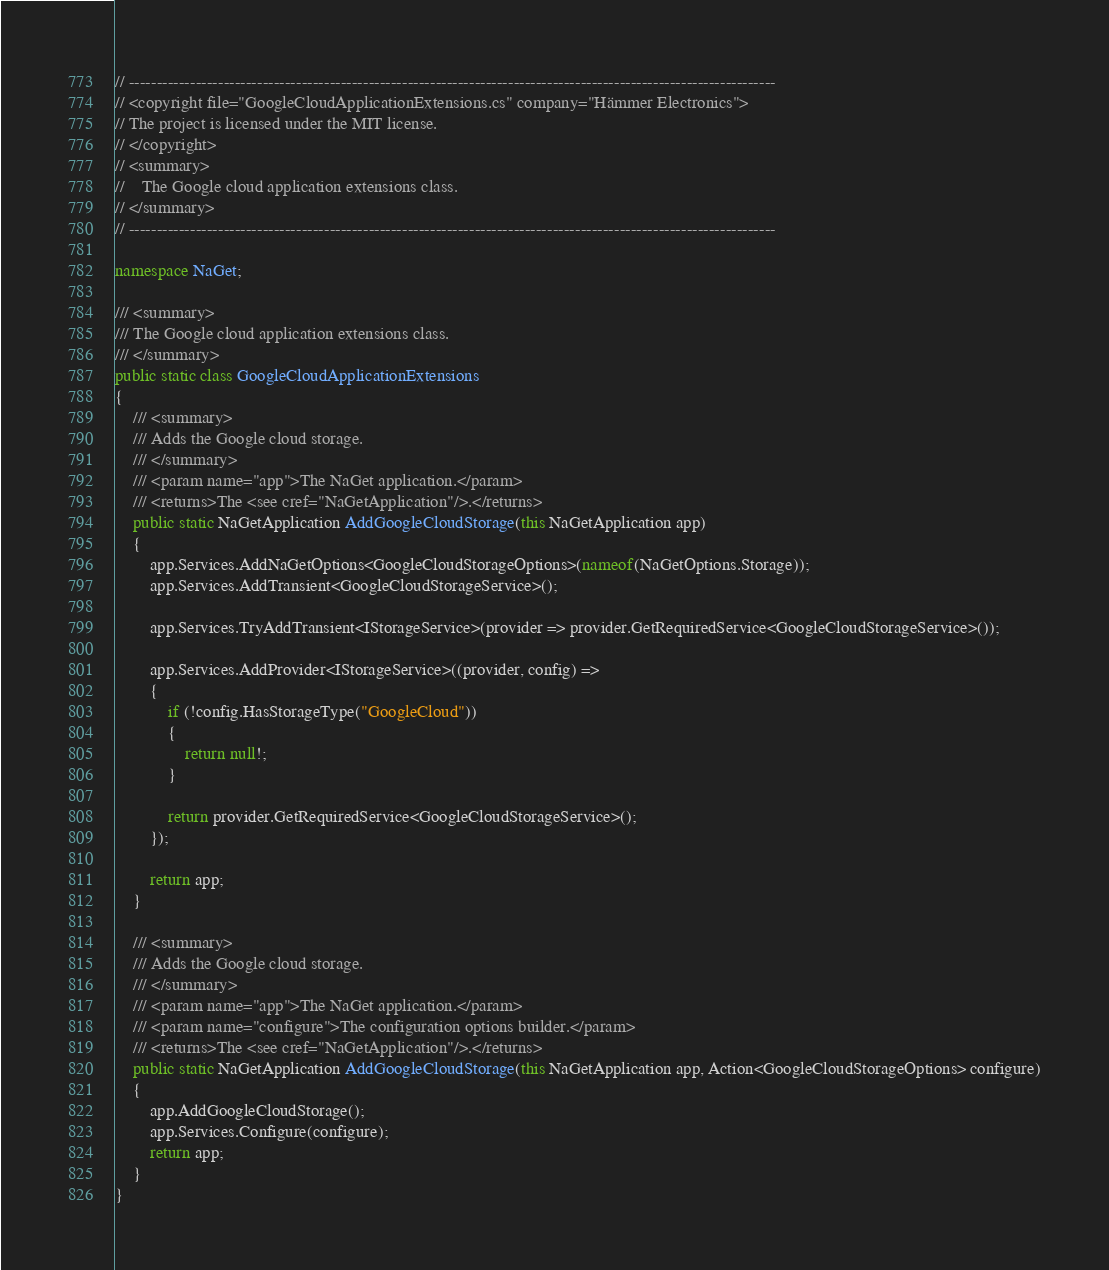Convert code to text. <code><loc_0><loc_0><loc_500><loc_500><_C#_>// --------------------------------------------------------------------------------------------------------------------
// <copyright file="GoogleCloudApplicationExtensions.cs" company="Hämmer Electronics">
// The project is licensed under the MIT license.
// </copyright>
// <summary>
//    The Google cloud application extensions class.
// </summary>
// --------------------------------------------------------------------------------------------------------------------

namespace NaGet;

/// <summary>
/// The Google cloud application extensions class.
/// </summary>
public static class GoogleCloudApplicationExtensions
{
    /// <summary>
    /// Adds the Google cloud storage.
    /// </summary>
    /// <param name="app">The NaGet application.</param>
    /// <returns>The <see cref="NaGetApplication"/>.</returns>
    public static NaGetApplication AddGoogleCloudStorage(this NaGetApplication app)
    {
        app.Services.AddNaGetOptions<GoogleCloudStorageOptions>(nameof(NaGetOptions.Storage));
        app.Services.AddTransient<GoogleCloudStorageService>();

        app.Services.TryAddTransient<IStorageService>(provider => provider.GetRequiredService<GoogleCloudStorageService>());

        app.Services.AddProvider<IStorageService>((provider, config) =>
        {
            if (!config.HasStorageType("GoogleCloud"))
            {
                return null!;
            }

            return provider.GetRequiredService<GoogleCloudStorageService>();
        });

        return app;
    }

    /// <summary>
    /// Adds the Google cloud storage.
    /// </summary>
    /// <param name="app">The NaGet application.</param>
    /// <param name="configure">The configuration options builder.</param>
    /// <returns>The <see cref="NaGetApplication"/>.</returns>
    public static NaGetApplication AddGoogleCloudStorage(this NaGetApplication app, Action<GoogleCloudStorageOptions> configure)
    {
        app.AddGoogleCloudStorage();
        app.Services.Configure(configure);
        return app;
    }
}
</code> 